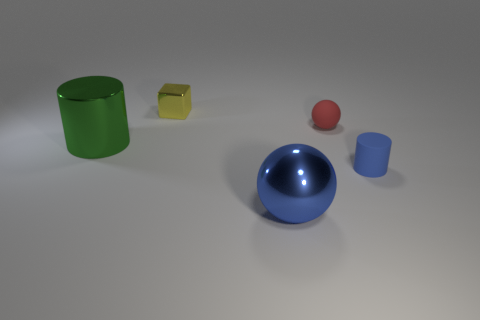Add 3 tiny blue cylinders. How many objects exist? 8 Subtract all blocks. How many objects are left? 4 Add 2 metallic cylinders. How many metallic cylinders exist? 3 Subtract 0 green balls. How many objects are left? 5 Subtract all large metal balls. Subtract all large blue spheres. How many objects are left? 3 Add 3 blue shiny spheres. How many blue shiny spheres are left? 4 